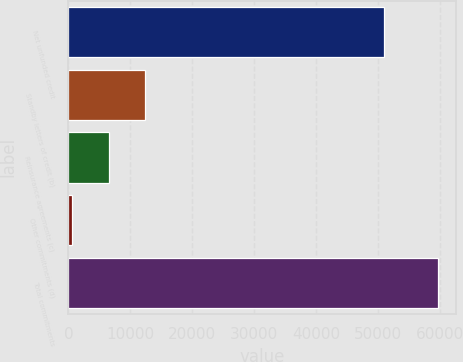Convert chart. <chart><loc_0><loc_0><loc_500><loc_500><bar_chart><fcel>Net unfunded credit<fcel>Standby letters of credit (b)<fcel>Reinsurance agreements (c)<fcel>Other commitments (d)<fcel>Total commitments<nl><fcel>51017<fcel>12412.4<fcel>6507.2<fcel>602<fcel>59654<nl></chart> 